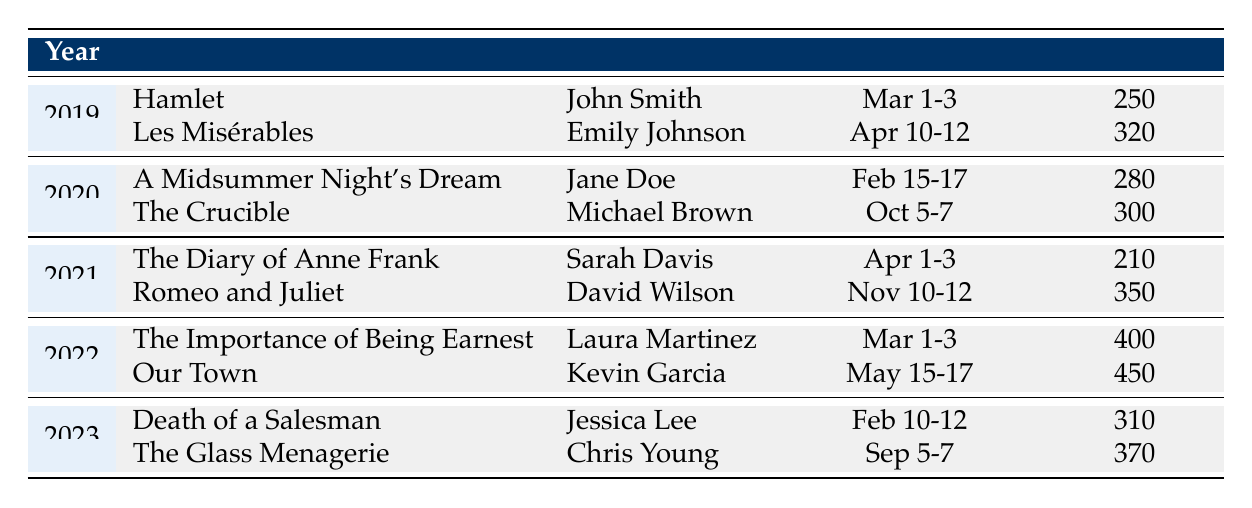What was the attendance of "Les Misérables"? Referring to the row for the year 2019 and the play title "Les Misérables," the attendance number is listed as 320.
Answer: 320 Which play had the highest attendance in 2022? In 2022, the table shows two plays: "The Importance of Being Earnest" with an attendance of 400 and "Our Town" with an attendance of 450. The highest attendance is 450 for "Our Town."
Answer: Our Town How many total performances were there in 2021? In 2021, there were two performances: "The Diary of Anne Frank" and "Romeo and Juliet." Therefore, the total number of performances is 2.
Answer: 2 What is the average attendance for all performances from 2019 to 2023? The total attendance across all listed performances is (250 + 320 + 280 + 300 + 210 + 350 + 400 + 450 + 310 + 370) = 3,240. There are a total of 10 performances. The average attendance is 3,240 / 10 = 324.
Answer: 324 Did "Death of a Salesman" have higher attendance than "The Crucible"? "Death of a Salesman" had an attendance of 310, while "The Crucible" had an attendance of 300. Since 310 > 300, the answer is yes.
Answer: Yes Which director had performances in both 2019 and 2023? The table does not list any director who had performances in both 2019 and 2023. Checking the directors: John Smith (2019), Emily Johnson (2019), Jessica Lee (2023), and Chris Young (2023) shows that no names are repeated across these years.
Answer: No What was the total attendance for all performances in 2020? In 2020, the attendances were 280 for "A Midsummer Night's Dream" and 300 for "The Crucible." Adding these gives 280 + 300 = 580.
Answer: 580 Which year had the highest total attendance? Calculating total attendance by year: 2019 (570), 2020 (580), 2021 (560), 2022 (850), and 2023 (680). The highest total attendance is in 2022: 850.
Answer: 2022 What was the attendance difference between "Romeo and Juliet" and "The Importance of Being Earnest"? The attendance of "Romeo and Juliet" is 350 and that of "The Importance of Being Earnest" is 400. The difference is calculated as 400 - 350 = 50.
Answer: 50 